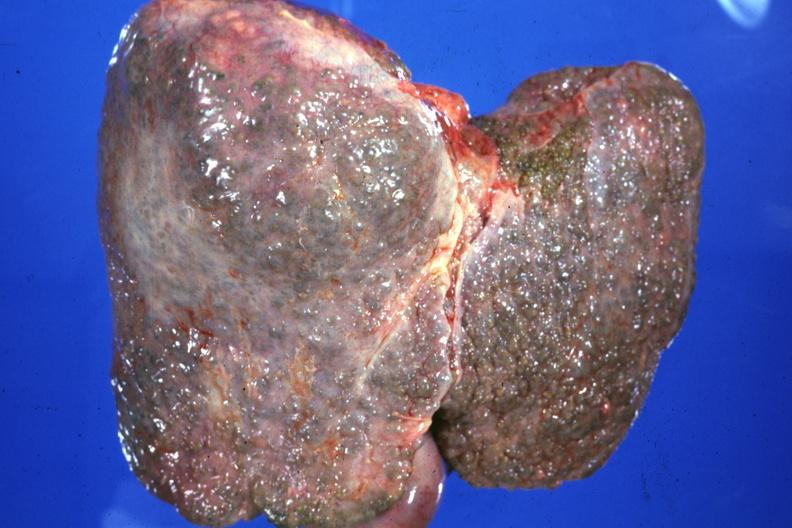does meningioma show external view typical alcoholic type cirrhosis?
Answer the question using a single word or phrase. No 